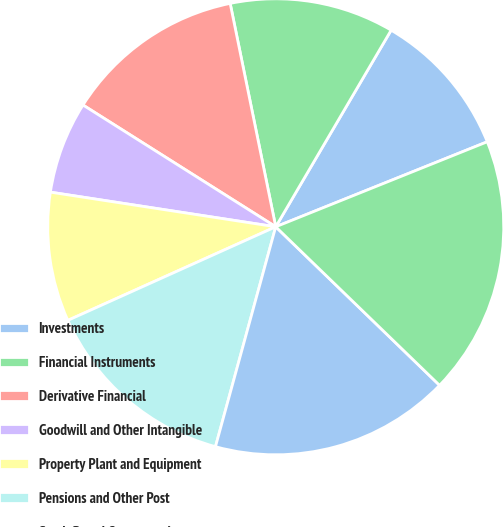Convert chart to OTSL. <chart><loc_0><loc_0><loc_500><loc_500><pie_chart><fcel>Investments<fcel>Financial Instruments<fcel>Derivative Financial<fcel>Goodwill and Other Intangible<fcel>Property Plant and Equipment<fcel>Pensions and Other Post<fcel>Stock-Based Compensation<fcel>Income Taxes<nl><fcel>10.47%<fcel>11.65%<fcel>12.83%<fcel>6.54%<fcel>9.16%<fcel>14.01%<fcel>17.02%<fcel>18.32%<nl></chart> 